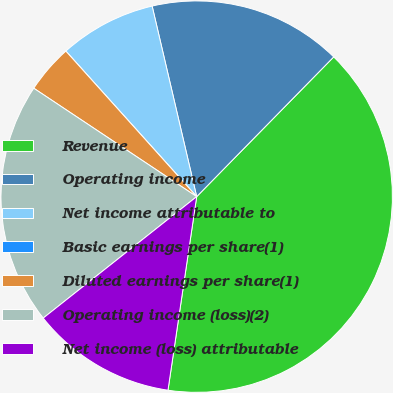<chart> <loc_0><loc_0><loc_500><loc_500><pie_chart><fcel>Revenue<fcel>Operating income<fcel>Net income attributable to<fcel>Basic earnings per share(1)<fcel>Diluted earnings per share(1)<fcel>Operating income (loss)(2)<fcel>Net income (loss) attributable<nl><fcel>40.0%<fcel>16.0%<fcel>8.0%<fcel>0.0%<fcel>4.0%<fcel>20.0%<fcel>12.0%<nl></chart> 